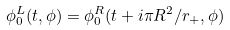Convert formula to latex. <formula><loc_0><loc_0><loc_500><loc_500>\phi _ { 0 } ^ { L } ( t , \phi ) = \phi _ { 0 } ^ { R } ( t + i \pi R ^ { 2 } / r _ { + } , \phi )</formula> 